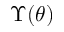Convert formula to latex. <formula><loc_0><loc_0><loc_500><loc_500>\Upsilon ( \theta )</formula> 